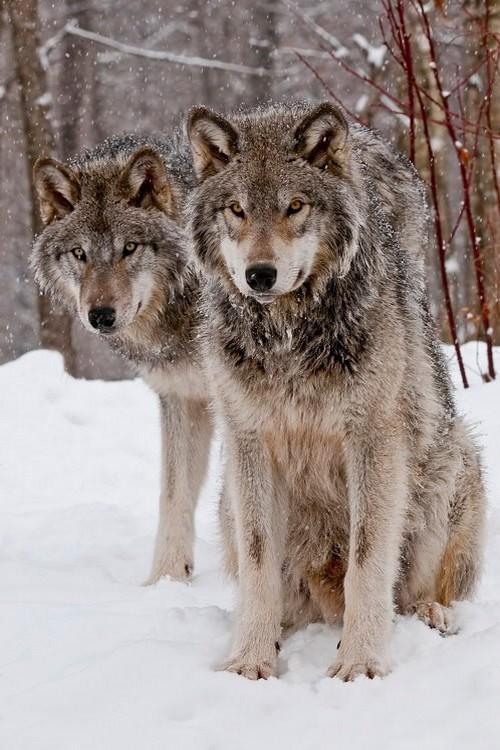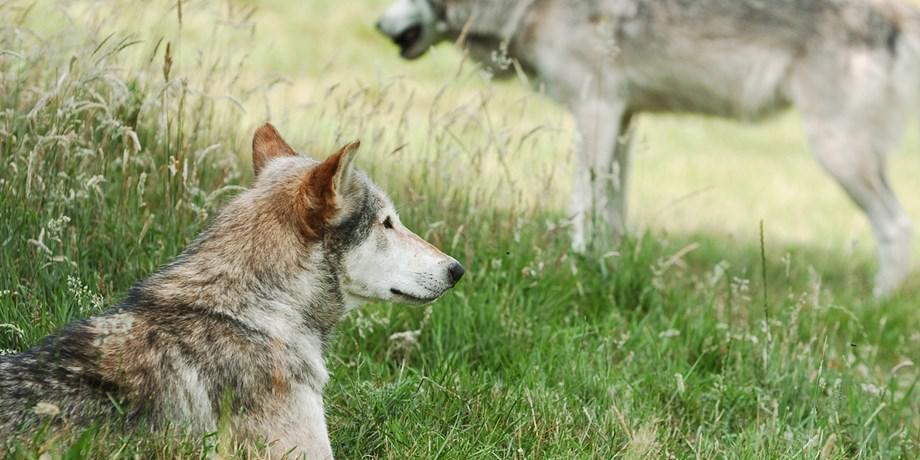The first image is the image on the left, the second image is the image on the right. Assess this claim about the two images: "There are at most two wolves total". Correct or not? Answer yes or no. No. The first image is the image on the left, the second image is the image on the right. Considering the images on both sides, is "There are a total of four wolves." valid? Answer yes or no. Yes. 